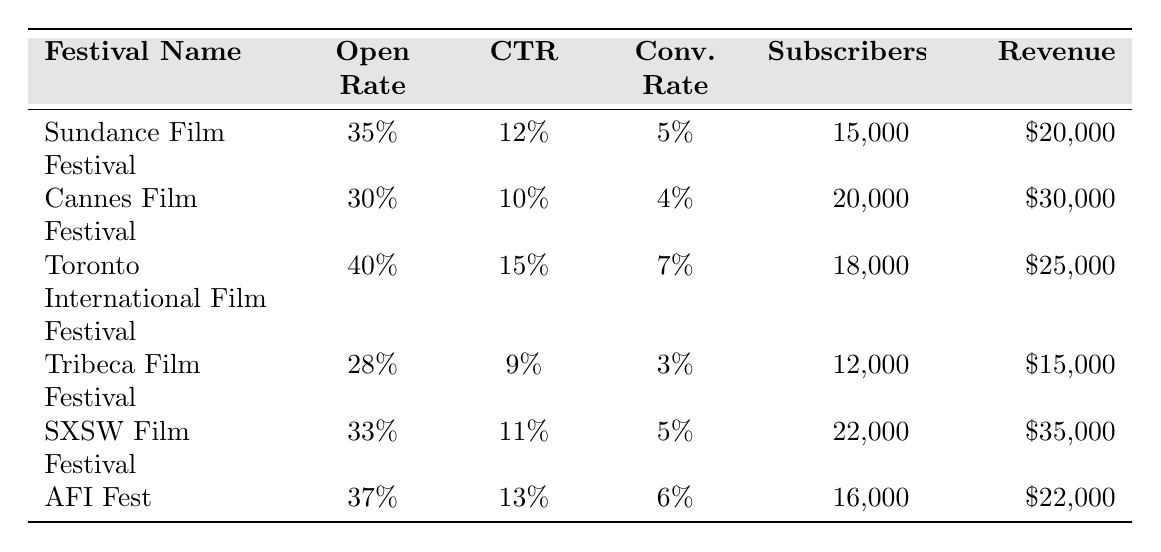What is the email open rate for the Toronto International Film Festival? From the table, the email open rate is listed directly next to the festival name. For the Toronto International Film Festival, it shows an open rate of 40%.
Answer: 40% Which festival had the highest click-through rate (CTR)? By comparing the CTR values for all festivals in the table, the Toronto International Film Festival has the highest click-through rate at 15%.
Answer: Toronto International Film Festival What is the conversion rate of the Tribeca Film Festival? The conversion rate for the Tribeca Film Festival is listed directly in the table, which shows a conversion rate of 3%.
Answer: 3% How many unique subscribers did the Sundance Film Festival have? The table indicates that the Sundance Film Festival had 15,000 unique subscribers listed next to its name.
Answer: 15,000 What is the total revenue generated by the SXSW Film Festival? According to the table, the total revenue generated by the SXSW Film Festival is $35,000, as mentioned in the corresponding cell.
Answer: $35,000 Which festival has a lower conversion rate, Cannes Film Festival or Tribeca Film Festival? Comparing the conversion rates from the table shows that Cannes Film Festival has a conversion rate of 4%, while Tribeca Film Festival has a conversion rate of 3%. Since 3% is lower than 4%, Tribeca Film Festival has the lower conversion rate.
Answer: Tribeca Film Festival What is the average email open rate across all festivals? To find the average, we add all the email open rates: (35 + 30 + 40 + 28 + 33 + 37) = 203%. There are 6 festivals, so we divide by 6: 203% / 6 = approximately 33.83%.
Answer: 33.83% Which festival had the most unique subscribers and how many did it have? Reviewing the unique subscriber counts, SXSW Film Festival has the highest number with 22,000 unique subscribers listed in the table.
Answer: SXSW Film Festival, 22,000 Is it true that AFI Fest generated more revenue than the Tribeca Film Festival? By checking the table, AFI Fest's revenue is $22,000, while Tribeca Film Festival's revenue is $15,000. Since $22,000 is greater than $15,000, the statement is true.
Answer: Yes What is the total revenue generated by the Sundance Film Festival and AFI Fest combined? The revenue for Sundance Film Festival is $20,000 and for AFI Fest is $22,000. Adding these together, $20,000 + $22,000 = $42,000.
Answer: $42,000 